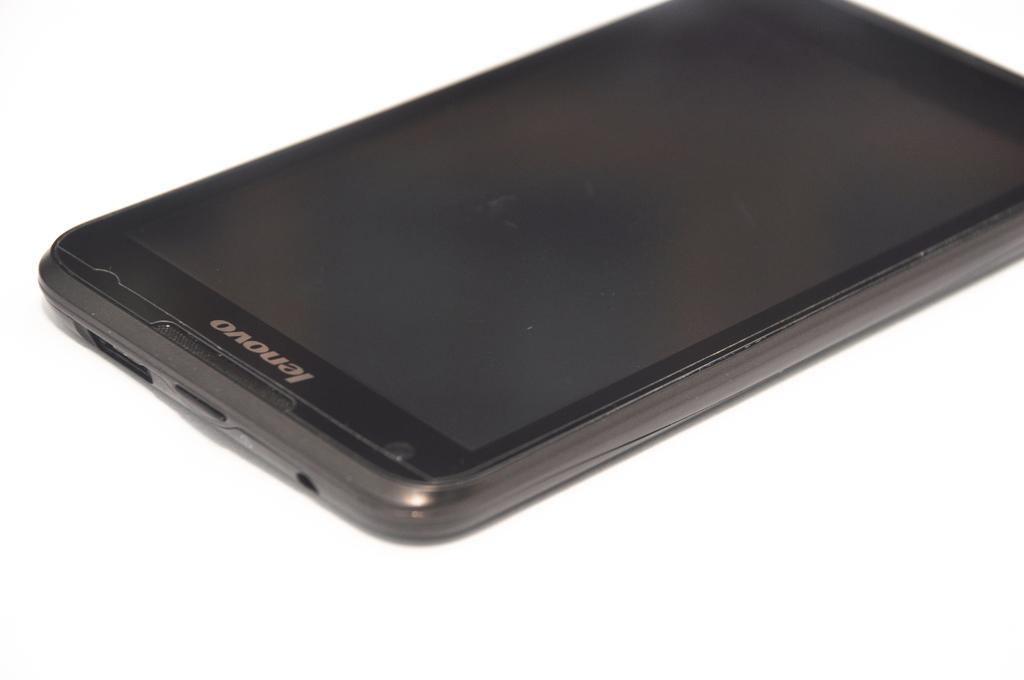<image>
Provide a brief description of the given image. A lenovo phone sits on a white table with the power off. 